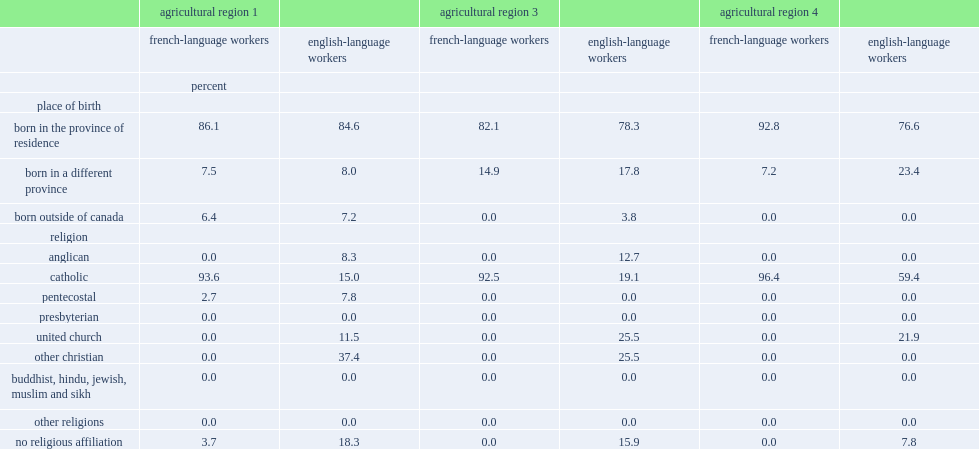What is the religion that is much more common among french-language workers than english-language workers? Catholic. 